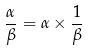Convert formula to latex. <formula><loc_0><loc_0><loc_500><loc_500>\frac { \alpha } { \beta } = \alpha \times \frac { 1 } { \beta }</formula> 